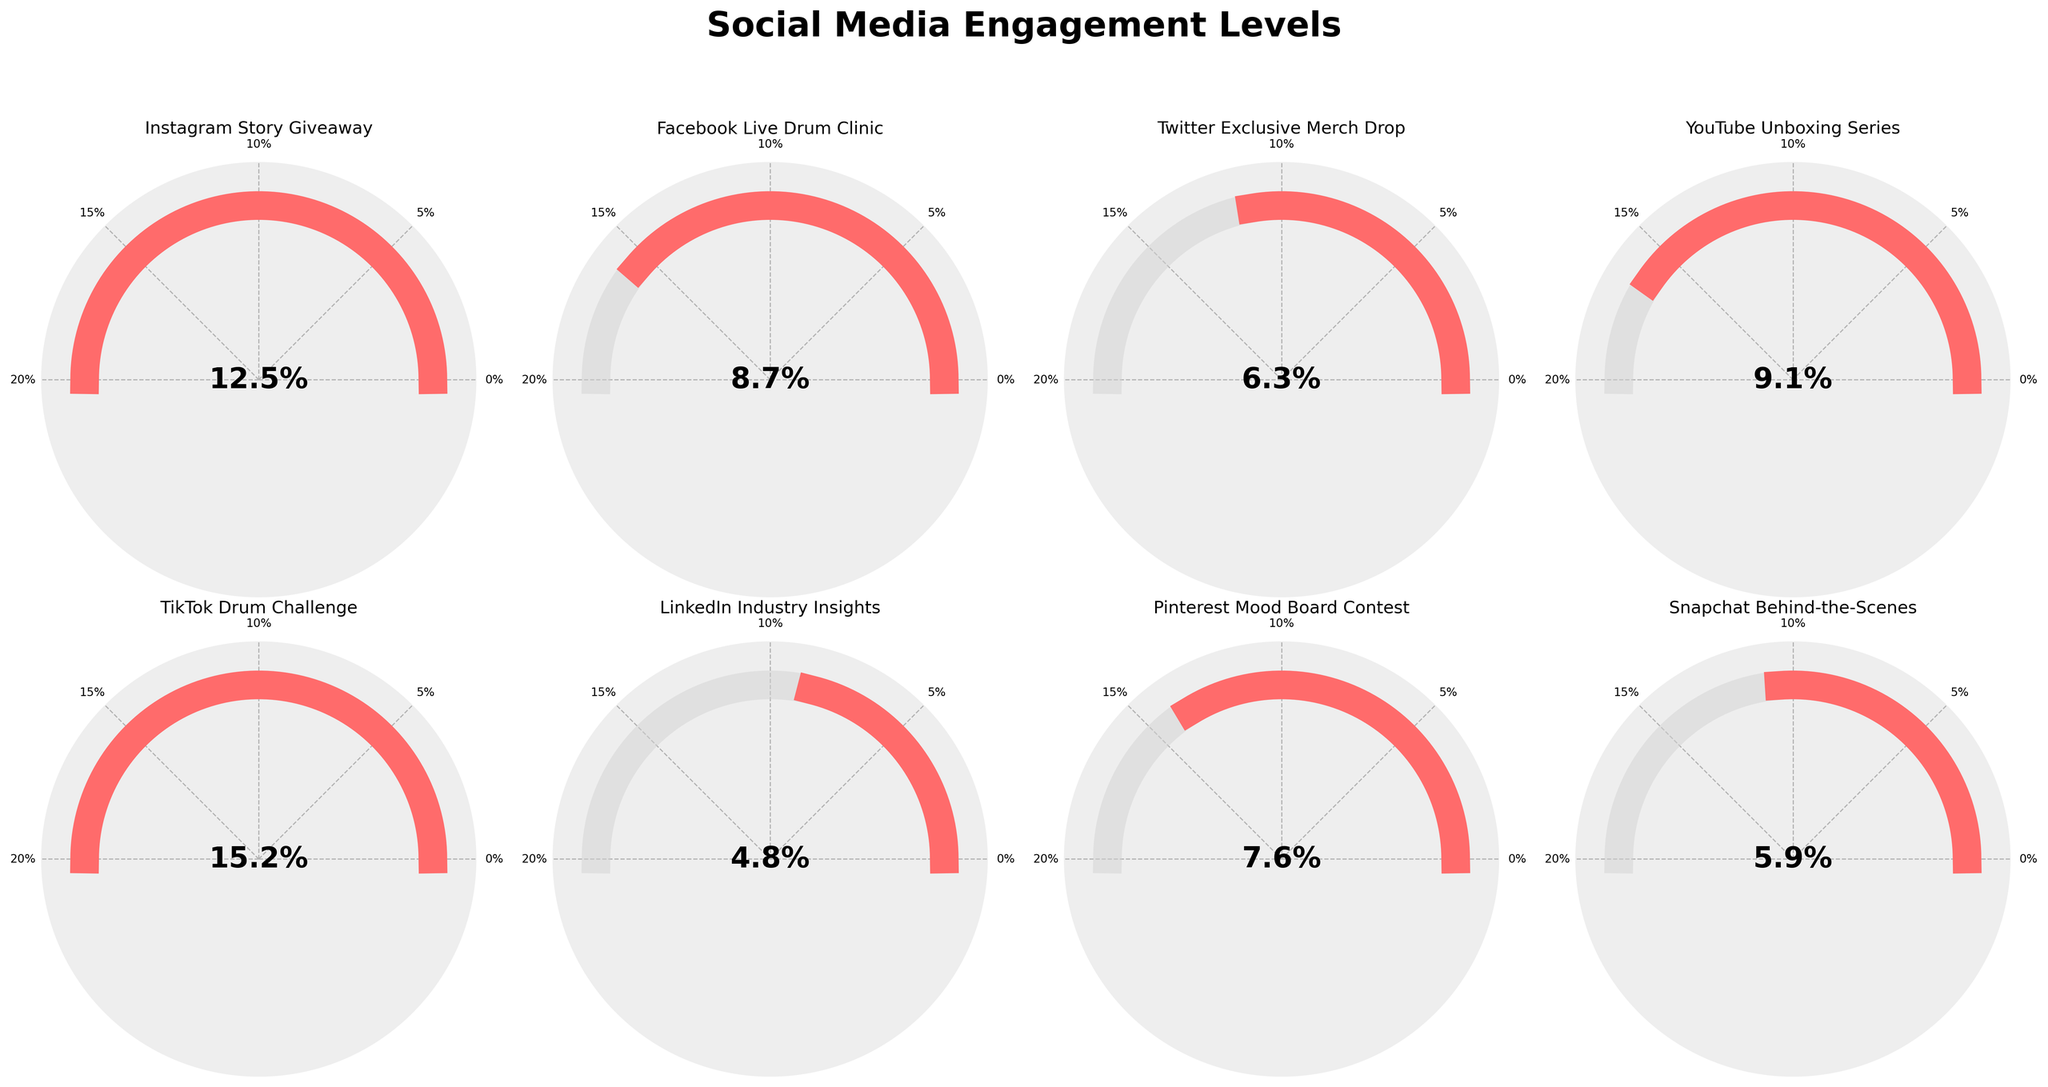How many different social media platforms are represented in the figure? There are 8 different gauge charts, each representing a different social media campaign. Each campaign corresponds to a different social media platform.
Answer: 8 Which campaign achieved the highest engagement percentage? The campaign with the highest engagement percentage is indicated by the gauge that has the needle furthest to the right. The "TikTok Drum Challenge" gauge reaches the furthest, indicating 15.2%.
Answer: TikTok Drum Challenge What is the engagement percentage for the "Facebook Live Drum Clinic" campaign? Locate the gauge chart titled "Facebook Live Drum Clinic". The percentage shown in the center of this gauge is 8.7%.
Answer: 8.7% How many campaigns achieved an engagement percentage above 10%? To determine this, count all gauge charts where the needle is past the 10% mark. Two campaigns "Instagram Story Giveaway" (12.5%) and "TikTok Drum Challenge" (15.2%) have percentages above 10%.
Answer: 2 What is the average engagement percentage across all campaigns? Add all the engagement percentages together: 12.5 + 8.7 + 6.3 + 9.1 + 15.2 + 4.8 + 7.6 + 5.9. The total is 70.1. Divide by the number of campaigns (8): 70.1 / 8.
Answer: 8.7625 Which campaign has a lower engagement percentage, "Twitter Exclusive Merch Drop" or "LinkedIn Industry Insights"? Compare the percentages shown on the gauge charts of the two campaigns. "Twitter Exclusive Merch Drop" shows 6.3%, and "LinkedIn Industry Insights" shows 4.8%. The lower percentage is for "LinkedIn Industry Insights".
Answer: LinkedIn Industry Insights What is the total engagement percentage for both "YouTube Unboxing Series" and "Pinterest Mood Board Contest"? Locate the percentages for both campaigns, which are 9.1% and 7.6%, respectively. Adding them together gives 9.1 + 7.6 = 16.7%.
Answer: 16.7% Which social media platform's campaign engagement is closest to the average engagement percentage? The average engagement percentage is 8.7625%. Compare each platform's engagement percentage to this value. "Facebook Live Drum Clinic" with 8.7% is closest to the average.
Answer: Facebook Live Drum Clinic Are there any campaigns with an engagement percentage below 5%? Identify any gauge charts where the needle is below the 5% mark. The "LinkedIn Industry Insights" with 4.8% is the only one below 5%.
Answer: Yes 